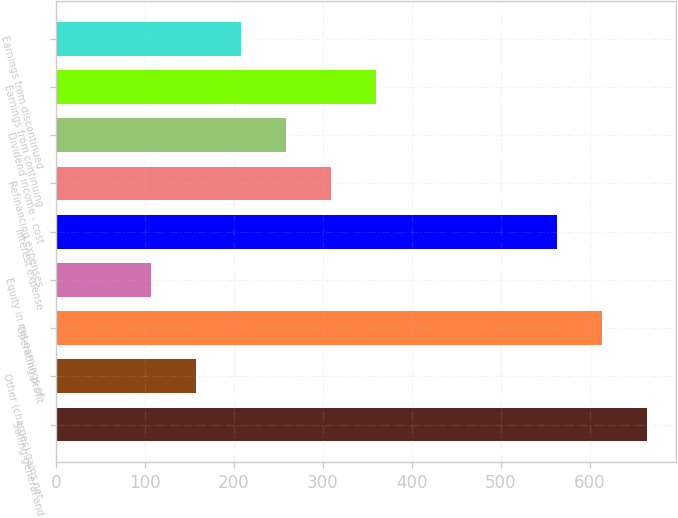Convert chart. <chart><loc_0><loc_0><loc_500><loc_500><bar_chart><fcel>Selling general and<fcel>Other (charges) gains net<fcel>Operating profit<fcel>Equity in net earnings of<fcel>Interest expense<fcel>Refinancing expenses<fcel>Dividend income - cost<fcel>Earnings from continuing<fcel>Earnings from discontinued<nl><fcel>664.04<fcel>157.24<fcel>613.36<fcel>106.56<fcel>562.68<fcel>309.28<fcel>258.6<fcel>359.96<fcel>207.92<nl></chart> 